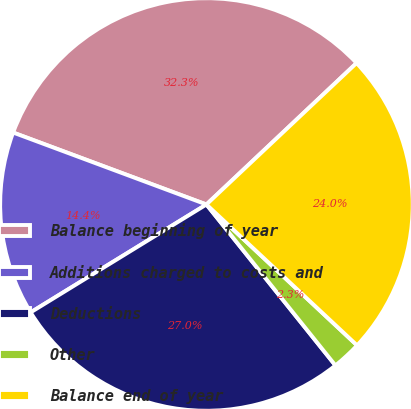Convert chart to OTSL. <chart><loc_0><loc_0><loc_500><loc_500><pie_chart><fcel>Balance beginning of year<fcel>Additions charged to costs and<fcel>Deductions<fcel>Other<fcel>Balance end of year<nl><fcel>32.3%<fcel>14.43%<fcel>26.99%<fcel>2.28%<fcel>23.99%<nl></chart> 